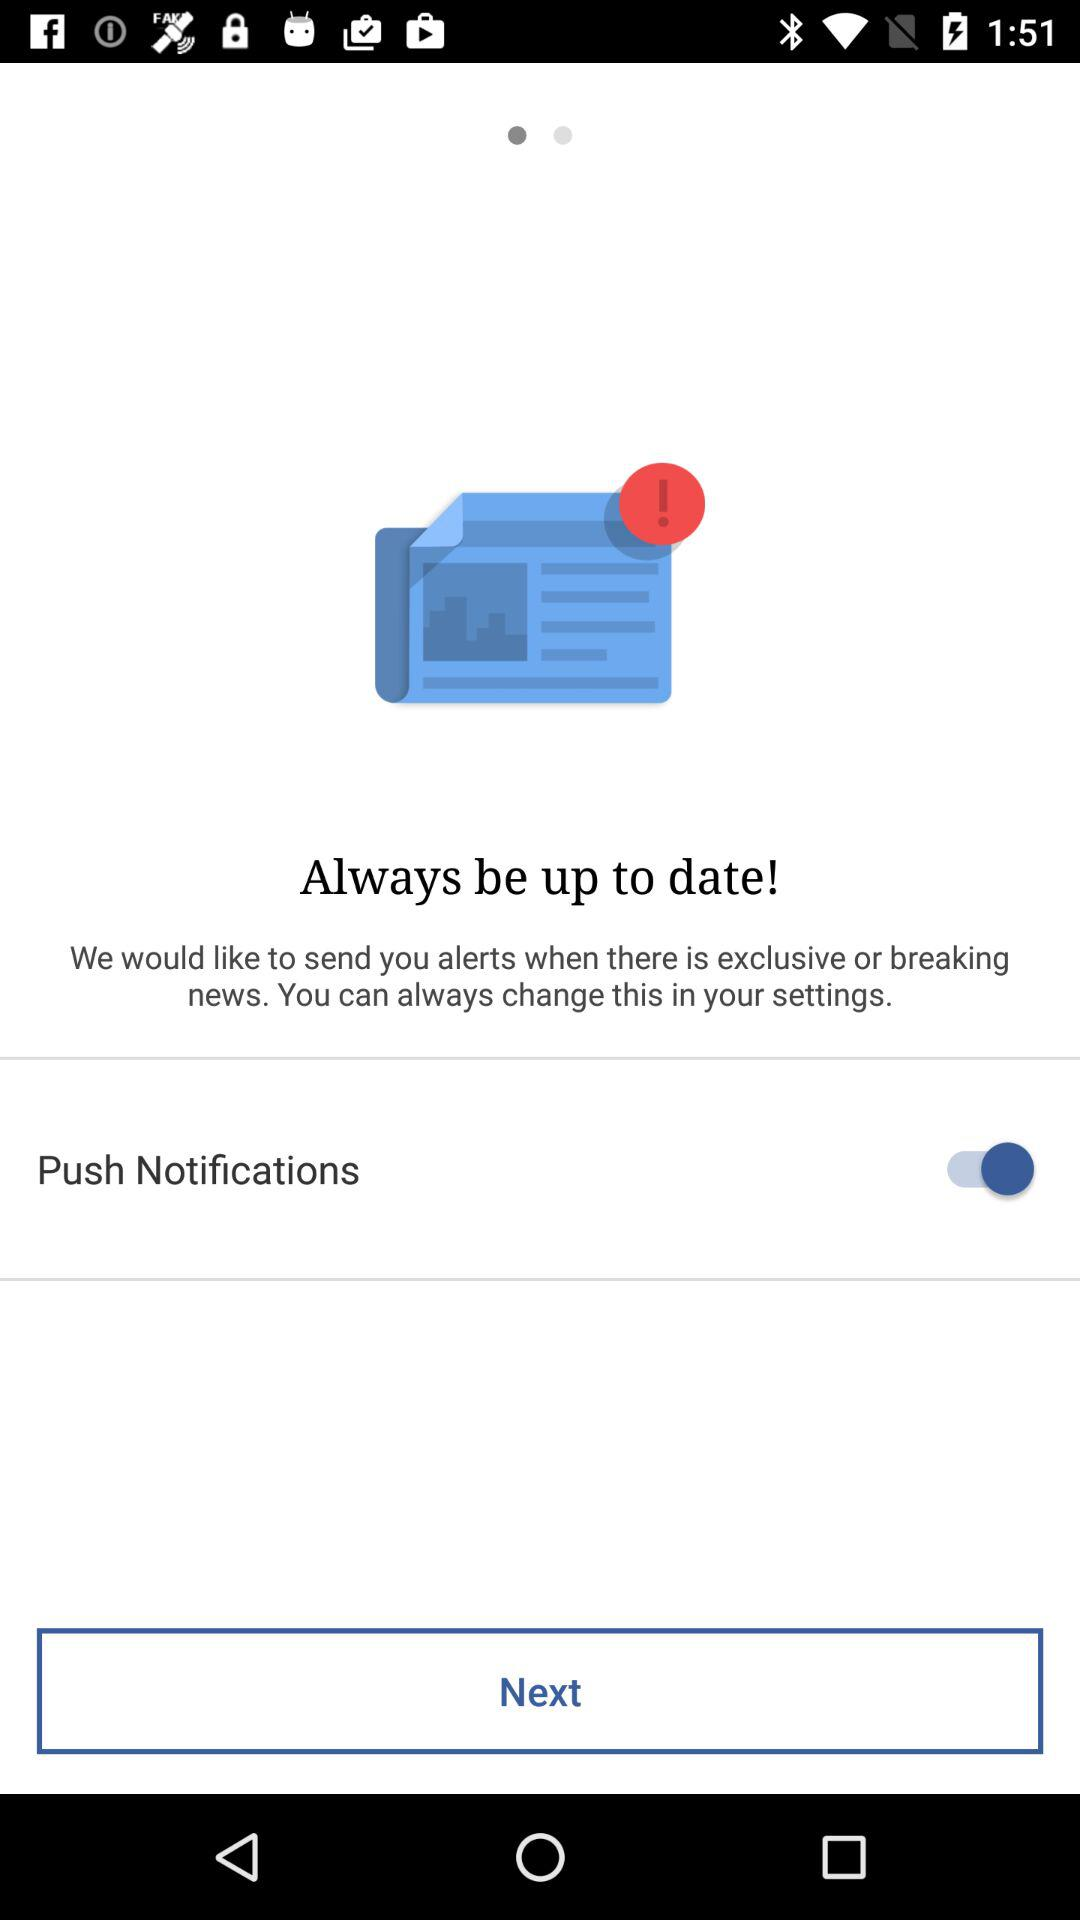How many breaking news alerts are there?
When the provided information is insufficient, respond with <no answer>. <no answer> 